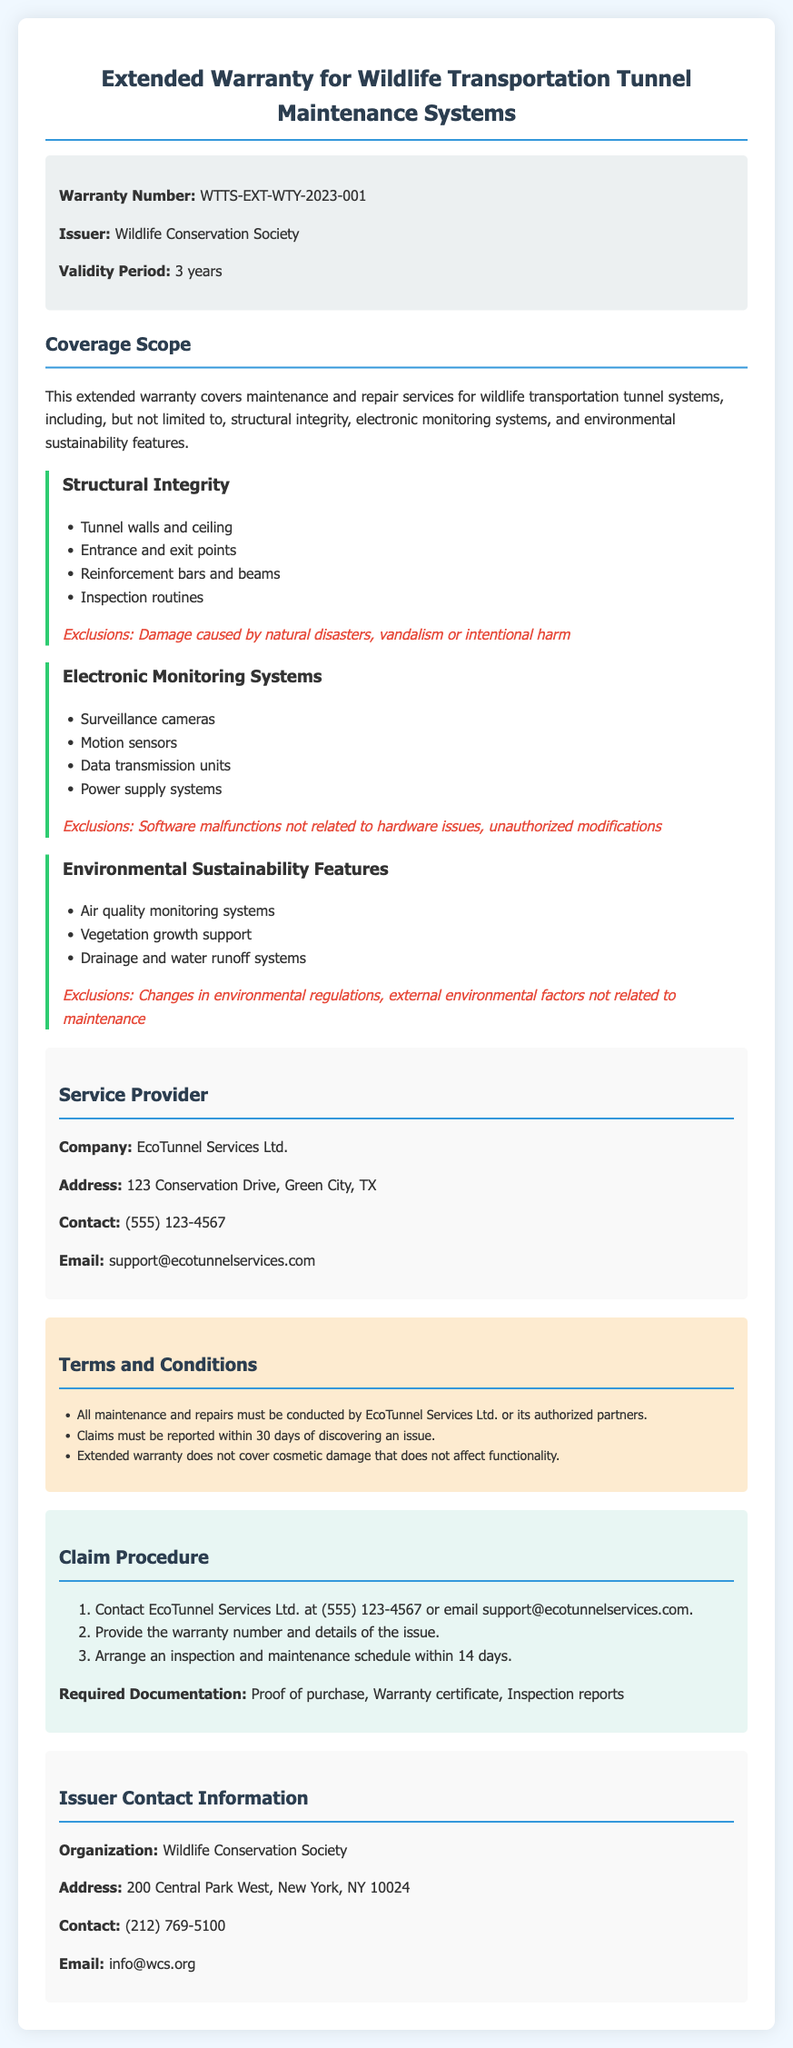What is the warranty number? The warranty number is listed in the document under the warranty info section.
Answer: WTTS-EXT-WTY-2023-001 Who is the issuer of the warranty? The issuer is explicitly stated in the warranty info section.
Answer: Wildlife Conservation Society What is the validity period of the warranty? The validity period is mentioned directly in the document.
Answer: 3 years Which company provides maintenance services? The service provider's details are specified in the service provider section.
Answer: EcoTunnel Services Ltd What is excluded from the structural integrity coverage? Exclusions for each coverage area are detailed in their respective sections.
Answer: Damage caused by natural disasters, vandalism or intentional harm What should be reported within 30 days? The terms mention specific claims that need to be reported during this timeframe.
Answer: Claims What is the required documentation for a claim? The claim procedure lists the documentation needed to file a claim.
Answer: Proof of purchase, Warranty certificate, Inspection reports How long do you have to arrange an inspection after reporting an issue? The claim procedure provides a specific timeframe for arranging inspections.
Answer: 14 days What feature does the environmental sustainability coverage include? Multiple features are outlined in the coverage scope for environmental sustainability.
Answer: Air quality monitoring systems 